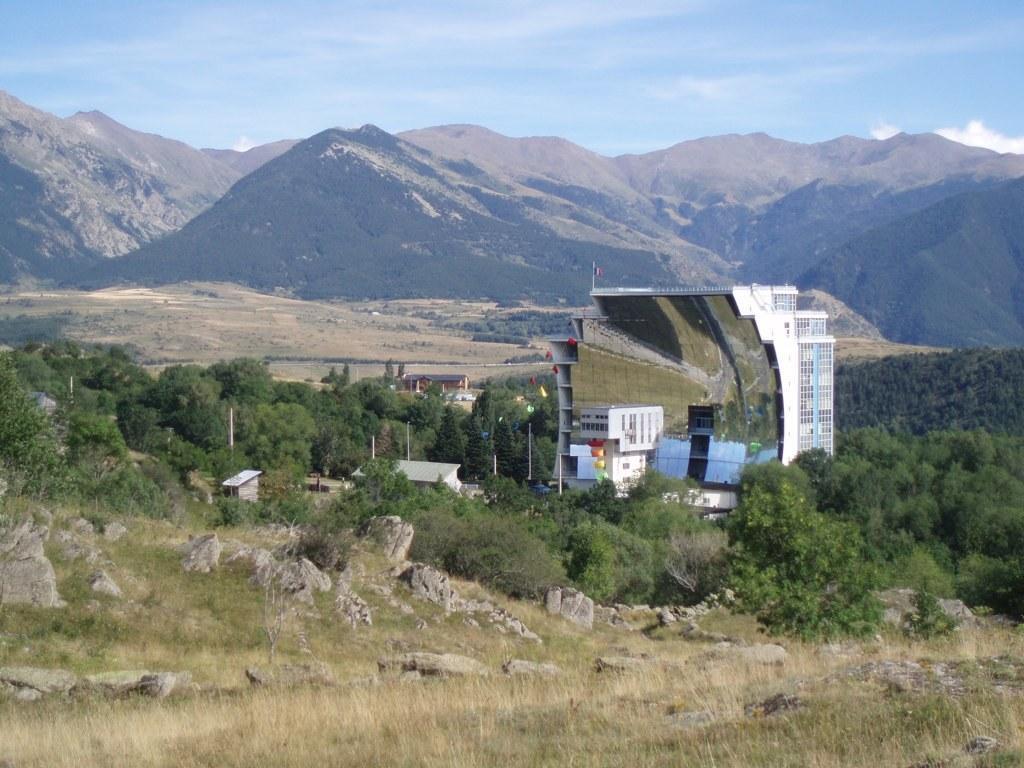Please provide a concise description of this image. At the bottom of the image there is grass. In the center of the image there are trees, buildings,poles. In the background of the image there are mountains. At the top of the image there is sky. 